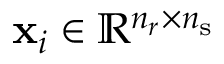<formula> <loc_0><loc_0><loc_500><loc_500>x _ { i } \in \mathbb { R } ^ { n _ { r } \times n _ { s } }</formula> 